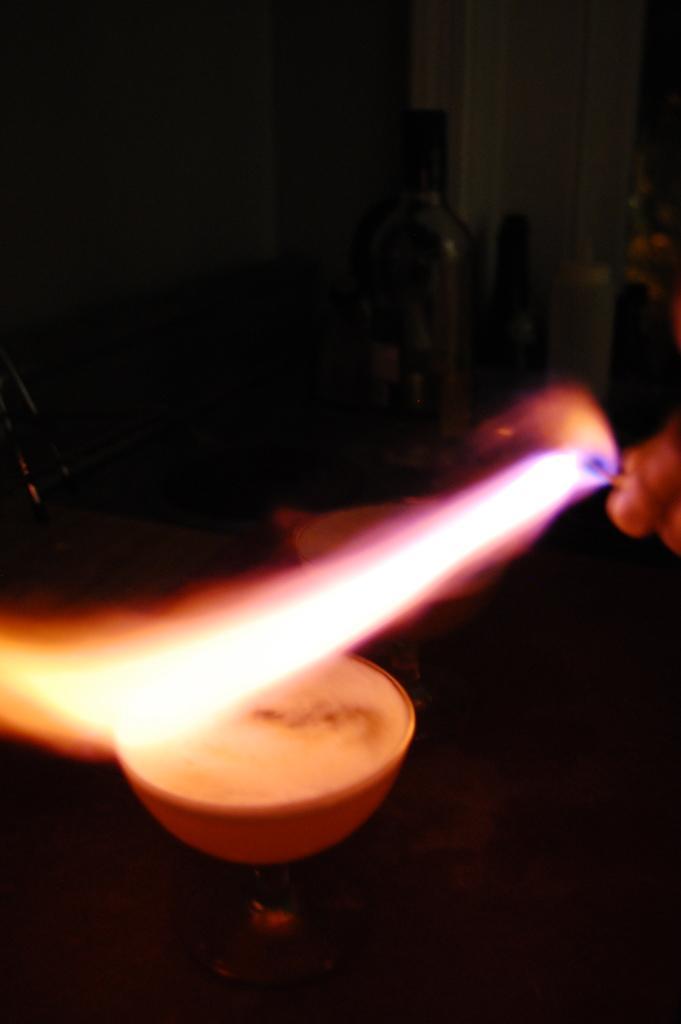Describe this image in one or two sentences. In this image we can see a person holding the matchstick with fire. 